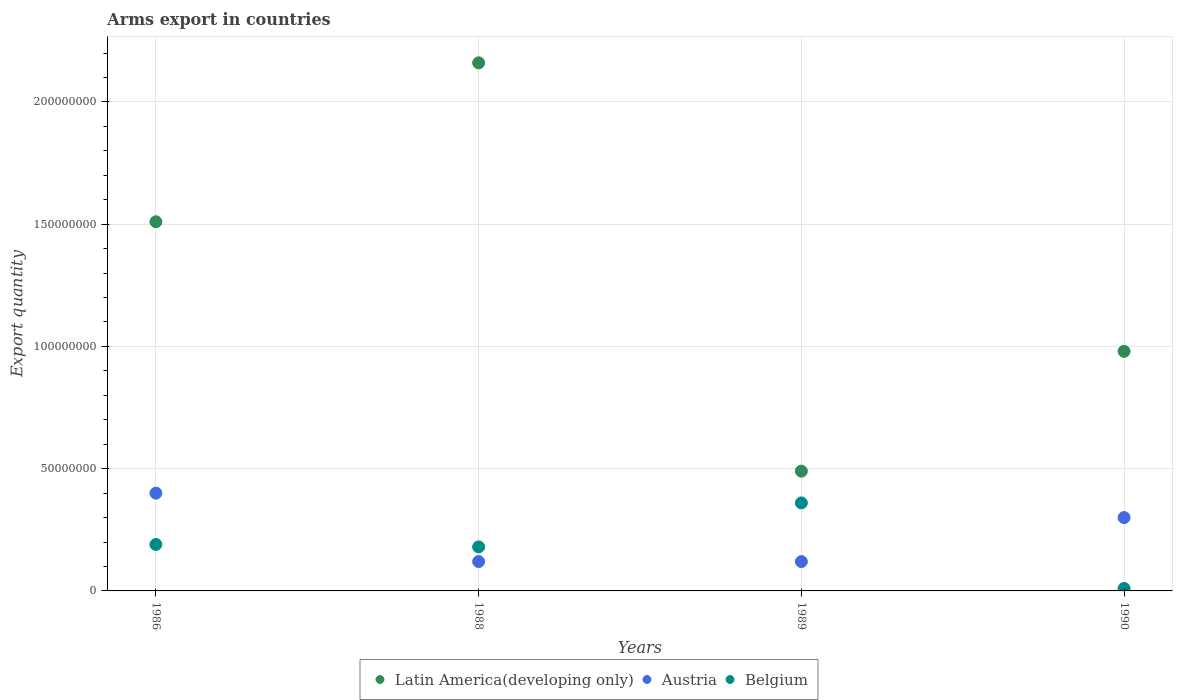Is the number of dotlines equal to the number of legend labels?
Offer a terse response. Yes. What is the total arms export in Latin America(developing only) in 1990?
Your response must be concise. 9.80e+07. Across all years, what is the maximum total arms export in Austria?
Make the answer very short. 4.00e+07. In which year was the total arms export in Belgium maximum?
Keep it short and to the point. 1989. What is the total total arms export in Latin America(developing only) in the graph?
Your answer should be very brief. 5.14e+08. What is the difference between the total arms export in Belgium in 1989 and that in 1990?
Offer a terse response. 3.50e+07. What is the difference between the total arms export in Latin America(developing only) in 1989 and the total arms export in Belgium in 1990?
Your answer should be very brief. 4.80e+07. What is the average total arms export in Austria per year?
Your answer should be compact. 2.35e+07. In the year 1990, what is the difference between the total arms export in Belgium and total arms export in Latin America(developing only)?
Ensure brevity in your answer.  -9.70e+07. In how many years, is the total arms export in Austria greater than 40000000?
Provide a short and direct response. 0. What is the ratio of the total arms export in Belgium in 1988 to that in 1989?
Offer a terse response. 0.5. Is the total arms export in Austria in 1986 less than that in 1989?
Your answer should be compact. No. What is the difference between the highest and the second highest total arms export in Latin America(developing only)?
Offer a very short reply. 6.50e+07. What is the difference between the highest and the lowest total arms export in Belgium?
Provide a short and direct response. 3.50e+07. In how many years, is the total arms export in Latin America(developing only) greater than the average total arms export in Latin America(developing only) taken over all years?
Your answer should be very brief. 2. Is the sum of the total arms export in Latin America(developing only) in 1988 and 1989 greater than the maximum total arms export in Belgium across all years?
Provide a short and direct response. Yes. Does the total arms export in Belgium monotonically increase over the years?
Keep it short and to the point. No. How many years are there in the graph?
Provide a short and direct response. 4. Does the graph contain grids?
Offer a terse response. Yes. How many legend labels are there?
Make the answer very short. 3. What is the title of the graph?
Your response must be concise. Arms export in countries. What is the label or title of the X-axis?
Keep it short and to the point. Years. What is the label or title of the Y-axis?
Ensure brevity in your answer.  Export quantity. What is the Export quantity of Latin America(developing only) in 1986?
Offer a very short reply. 1.51e+08. What is the Export quantity in Austria in 1986?
Offer a very short reply. 4.00e+07. What is the Export quantity in Belgium in 1986?
Make the answer very short. 1.90e+07. What is the Export quantity in Latin America(developing only) in 1988?
Make the answer very short. 2.16e+08. What is the Export quantity in Austria in 1988?
Your answer should be very brief. 1.20e+07. What is the Export quantity in Belgium in 1988?
Offer a very short reply. 1.80e+07. What is the Export quantity in Latin America(developing only) in 1989?
Make the answer very short. 4.90e+07. What is the Export quantity of Austria in 1989?
Your answer should be compact. 1.20e+07. What is the Export quantity in Belgium in 1989?
Offer a terse response. 3.60e+07. What is the Export quantity of Latin America(developing only) in 1990?
Ensure brevity in your answer.  9.80e+07. What is the Export quantity in Austria in 1990?
Make the answer very short. 3.00e+07. Across all years, what is the maximum Export quantity in Latin America(developing only)?
Keep it short and to the point. 2.16e+08. Across all years, what is the maximum Export quantity of Austria?
Your answer should be compact. 4.00e+07. Across all years, what is the maximum Export quantity in Belgium?
Your response must be concise. 3.60e+07. Across all years, what is the minimum Export quantity in Latin America(developing only)?
Offer a very short reply. 4.90e+07. Across all years, what is the minimum Export quantity in Austria?
Give a very brief answer. 1.20e+07. What is the total Export quantity in Latin America(developing only) in the graph?
Provide a succinct answer. 5.14e+08. What is the total Export quantity of Austria in the graph?
Provide a succinct answer. 9.40e+07. What is the total Export quantity in Belgium in the graph?
Offer a very short reply. 7.40e+07. What is the difference between the Export quantity of Latin America(developing only) in 1986 and that in 1988?
Your answer should be very brief. -6.50e+07. What is the difference between the Export quantity of Austria in 1986 and that in 1988?
Your answer should be very brief. 2.80e+07. What is the difference between the Export quantity of Belgium in 1986 and that in 1988?
Make the answer very short. 1.00e+06. What is the difference between the Export quantity of Latin America(developing only) in 1986 and that in 1989?
Provide a short and direct response. 1.02e+08. What is the difference between the Export quantity of Austria in 1986 and that in 1989?
Your response must be concise. 2.80e+07. What is the difference between the Export quantity in Belgium in 1986 and that in 1989?
Your answer should be very brief. -1.70e+07. What is the difference between the Export quantity in Latin America(developing only) in 1986 and that in 1990?
Offer a terse response. 5.30e+07. What is the difference between the Export quantity in Belgium in 1986 and that in 1990?
Give a very brief answer. 1.80e+07. What is the difference between the Export quantity in Latin America(developing only) in 1988 and that in 1989?
Make the answer very short. 1.67e+08. What is the difference between the Export quantity of Austria in 1988 and that in 1989?
Make the answer very short. 0. What is the difference between the Export quantity of Belgium in 1988 and that in 1989?
Provide a short and direct response. -1.80e+07. What is the difference between the Export quantity in Latin America(developing only) in 1988 and that in 1990?
Your answer should be very brief. 1.18e+08. What is the difference between the Export quantity of Austria in 1988 and that in 1990?
Offer a terse response. -1.80e+07. What is the difference between the Export quantity of Belgium in 1988 and that in 1990?
Provide a short and direct response. 1.70e+07. What is the difference between the Export quantity in Latin America(developing only) in 1989 and that in 1990?
Provide a short and direct response. -4.90e+07. What is the difference between the Export quantity in Austria in 1989 and that in 1990?
Provide a short and direct response. -1.80e+07. What is the difference between the Export quantity of Belgium in 1989 and that in 1990?
Give a very brief answer. 3.50e+07. What is the difference between the Export quantity of Latin America(developing only) in 1986 and the Export quantity of Austria in 1988?
Your answer should be compact. 1.39e+08. What is the difference between the Export quantity in Latin America(developing only) in 1986 and the Export quantity in Belgium in 1988?
Offer a terse response. 1.33e+08. What is the difference between the Export quantity of Austria in 1986 and the Export quantity of Belgium in 1988?
Your response must be concise. 2.20e+07. What is the difference between the Export quantity in Latin America(developing only) in 1986 and the Export quantity in Austria in 1989?
Provide a short and direct response. 1.39e+08. What is the difference between the Export quantity of Latin America(developing only) in 1986 and the Export quantity of Belgium in 1989?
Give a very brief answer. 1.15e+08. What is the difference between the Export quantity of Austria in 1986 and the Export quantity of Belgium in 1989?
Your answer should be very brief. 4.00e+06. What is the difference between the Export quantity in Latin America(developing only) in 1986 and the Export quantity in Austria in 1990?
Give a very brief answer. 1.21e+08. What is the difference between the Export quantity of Latin America(developing only) in 1986 and the Export quantity of Belgium in 1990?
Make the answer very short. 1.50e+08. What is the difference between the Export quantity in Austria in 1986 and the Export quantity in Belgium in 1990?
Your answer should be compact. 3.90e+07. What is the difference between the Export quantity in Latin America(developing only) in 1988 and the Export quantity in Austria in 1989?
Ensure brevity in your answer.  2.04e+08. What is the difference between the Export quantity in Latin America(developing only) in 1988 and the Export quantity in Belgium in 1989?
Your answer should be compact. 1.80e+08. What is the difference between the Export quantity in Austria in 1988 and the Export quantity in Belgium in 1989?
Offer a terse response. -2.40e+07. What is the difference between the Export quantity of Latin America(developing only) in 1988 and the Export quantity of Austria in 1990?
Make the answer very short. 1.86e+08. What is the difference between the Export quantity in Latin America(developing only) in 1988 and the Export quantity in Belgium in 1990?
Keep it short and to the point. 2.15e+08. What is the difference between the Export quantity in Austria in 1988 and the Export quantity in Belgium in 1990?
Offer a terse response. 1.10e+07. What is the difference between the Export quantity of Latin America(developing only) in 1989 and the Export quantity of Austria in 1990?
Ensure brevity in your answer.  1.90e+07. What is the difference between the Export quantity in Latin America(developing only) in 1989 and the Export quantity in Belgium in 1990?
Provide a short and direct response. 4.80e+07. What is the difference between the Export quantity of Austria in 1989 and the Export quantity of Belgium in 1990?
Make the answer very short. 1.10e+07. What is the average Export quantity of Latin America(developing only) per year?
Make the answer very short. 1.28e+08. What is the average Export quantity of Austria per year?
Give a very brief answer. 2.35e+07. What is the average Export quantity in Belgium per year?
Provide a short and direct response. 1.85e+07. In the year 1986, what is the difference between the Export quantity of Latin America(developing only) and Export quantity of Austria?
Keep it short and to the point. 1.11e+08. In the year 1986, what is the difference between the Export quantity in Latin America(developing only) and Export quantity in Belgium?
Your response must be concise. 1.32e+08. In the year 1986, what is the difference between the Export quantity in Austria and Export quantity in Belgium?
Make the answer very short. 2.10e+07. In the year 1988, what is the difference between the Export quantity of Latin America(developing only) and Export quantity of Austria?
Offer a very short reply. 2.04e+08. In the year 1988, what is the difference between the Export quantity of Latin America(developing only) and Export quantity of Belgium?
Offer a very short reply. 1.98e+08. In the year 1988, what is the difference between the Export quantity in Austria and Export quantity in Belgium?
Provide a succinct answer. -6.00e+06. In the year 1989, what is the difference between the Export quantity of Latin America(developing only) and Export quantity of Austria?
Your answer should be very brief. 3.70e+07. In the year 1989, what is the difference between the Export quantity of Latin America(developing only) and Export quantity of Belgium?
Give a very brief answer. 1.30e+07. In the year 1989, what is the difference between the Export quantity of Austria and Export quantity of Belgium?
Make the answer very short. -2.40e+07. In the year 1990, what is the difference between the Export quantity of Latin America(developing only) and Export quantity of Austria?
Your answer should be compact. 6.80e+07. In the year 1990, what is the difference between the Export quantity in Latin America(developing only) and Export quantity in Belgium?
Your answer should be very brief. 9.70e+07. In the year 1990, what is the difference between the Export quantity of Austria and Export quantity of Belgium?
Make the answer very short. 2.90e+07. What is the ratio of the Export quantity of Latin America(developing only) in 1986 to that in 1988?
Make the answer very short. 0.7. What is the ratio of the Export quantity in Belgium in 1986 to that in 1988?
Your answer should be compact. 1.06. What is the ratio of the Export quantity in Latin America(developing only) in 1986 to that in 1989?
Provide a short and direct response. 3.08. What is the ratio of the Export quantity of Belgium in 1986 to that in 1989?
Your response must be concise. 0.53. What is the ratio of the Export quantity in Latin America(developing only) in 1986 to that in 1990?
Give a very brief answer. 1.54. What is the ratio of the Export quantity of Austria in 1986 to that in 1990?
Your answer should be very brief. 1.33. What is the ratio of the Export quantity of Latin America(developing only) in 1988 to that in 1989?
Keep it short and to the point. 4.41. What is the ratio of the Export quantity in Austria in 1988 to that in 1989?
Offer a very short reply. 1. What is the ratio of the Export quantity of Belgium in 1988 to that in 1989?
Make the answer very short. 0.5. What is the ratio of the Export quantity of Latin America(developing only) in 1988 to that in 1990?
Your answer should be very brief. 2.2. What is the ratio of the Export quantity in Latin America(developing only) in 1989 to that in 1990?
Provide a short and direct response. 0.5. What is the difference between the highest and the second highest Export quantity of Latin America(developing only)?
Make the answer very short. 6.50e+07. What is the difference between the highest and the second highest Export quantity of Austria?
Your response must be concise. 1.00e+07. What is the difference between the highest and the second highest Export quantity in Belgium?
Your answer should be compact. 1.70e+07. What is the difference between the highest and the lowest Export quantity in Latin America(developing only)?
Give a very brief answer. 1.67e+08. What is the difference between the highest and the lowest Export quantity of Austria?
Your answer should be compact. 2.80e+07. What is the difference between the highest and the lowest Export quantity of Belgium?
Make the answer very short. 3.50e+07. 